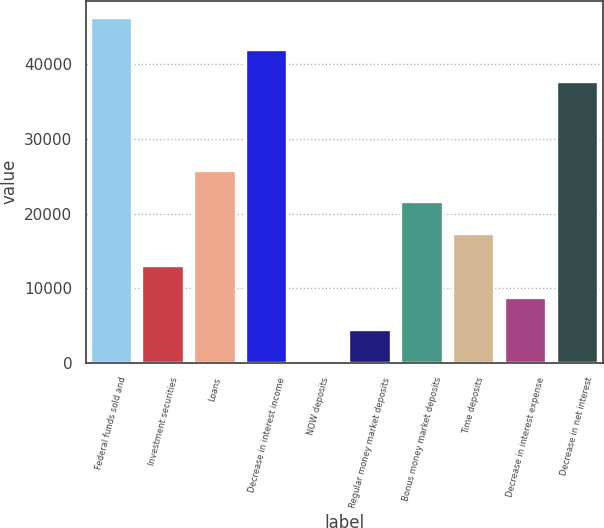Convert chart. <chart><loc_0><loc_0><loc_500><loc_500><bar_chart><fcel>Federal funds sold and<fcel>Investment securities<fcel>Loans<fcel>Decrease in interest income<fcel>NOW deposits<fcel>Regular money market deposits<fcel>Bonus money market deposits<fcel>Time deposits<fcel>Decrease in interest expense<fcel>Decrease in net interest<nl><fcel>46207.8<fcel>12963.7<fcel>25764.4<fcel>41940.9<fcel>163<fcel>4429.9<fcel>21497.5<fcel>17230.6<fcel>8696.8<fcel>37674<nl></chart> 